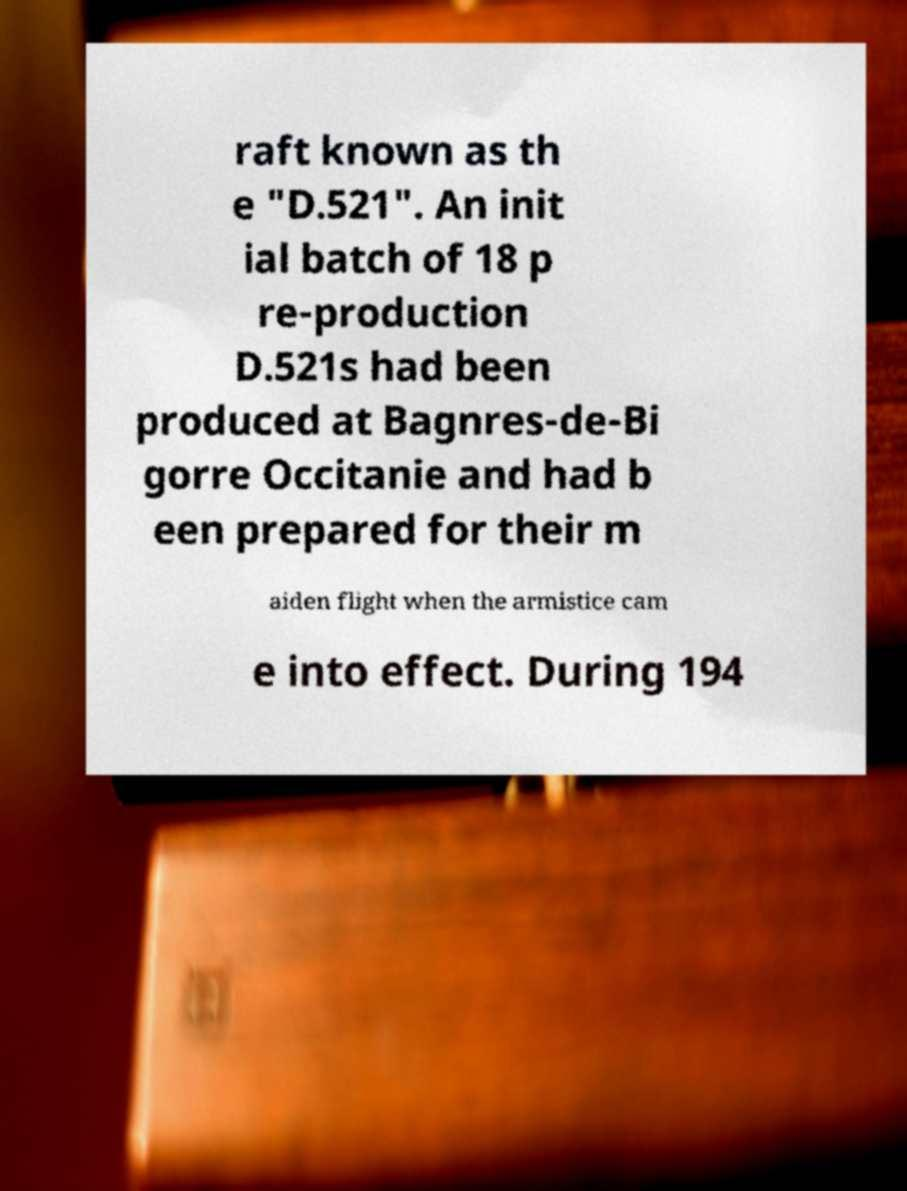Could you extract and type out the text from this image? raft known as th e "D.521". An init ial batch of 18 p re-production D.521s had been produced at Bagnres-de-Bi gorre Occitanie and had b een prepared for their m aiden flight when the armistice cam e into effect. During 194 